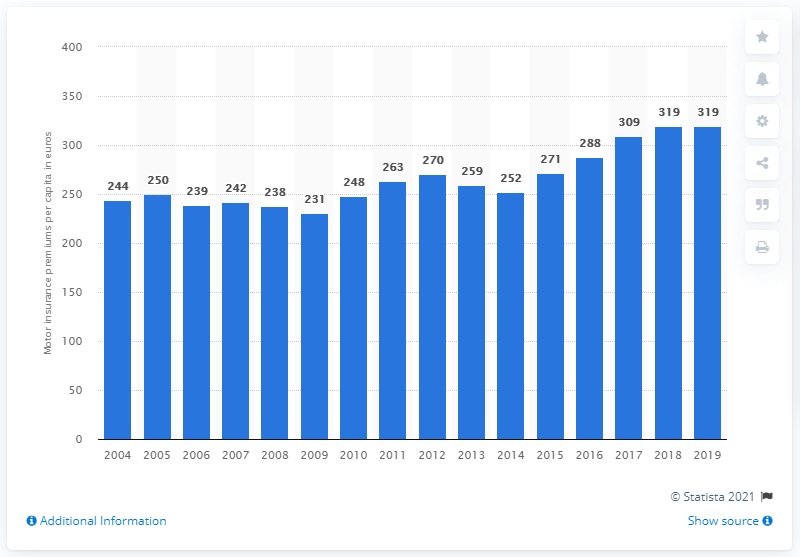Can you infer the possible reasons for the fluctuations in the premium costs? While specific reasons for the fluctuations aren't provided in the graph, these can typically be attributed to several factors such as changes in healthcare policies, economic inflation, alterations in healthcare service costs, and demographic shifts affecting the insured population. 